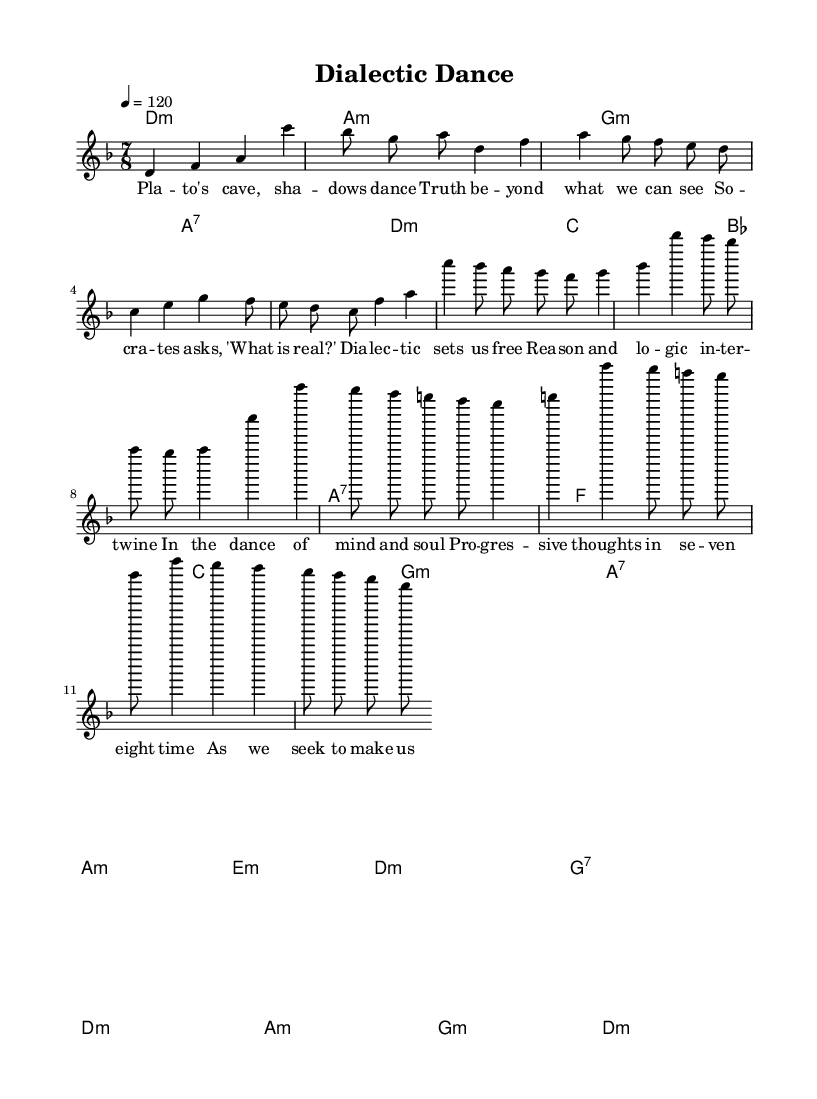What is the key signature of this music? The key signature is indicated at the beginning of the staff, showing one flat (B flat), which corresponds to D minor.
Answer: D minor What is the time signature of the piece? The time signature is found at the beginning of the music, indicating that there are seven beats per measure, which is expressed as 7/8.
Answer: 7/8 What is the tempo of the piece? The tempo marking shows "4 = 120", meaning there are 120 beats per minute, and each quarter note is to be played at this speed.
Answer: 120 How many sections are in the composition? By analyzing the structure, there are five distinct sections present: Intro, Verse, Chorus, Bridge, and Outro, as outlined in the music.
Answer: Five What is the mood conveyed through the song's title? The title "Dialectic Dance" suggests an exploration of philosophical ideas through the metaphor of dancing, implying a lively yet reflective mood.
Answer: Reflective How many words are in the first verse? The first verse has four lines of lyrics, and counting each word gives a total of 20 words.
Answer: 20 What instruments are likely used in this genre fusion? Considering the style of progressive rock-folk fusion, common instruments would include electric guitar, acoustic guitar, and keyboards, which might be inferred from the harmonies and melody.
Answer: Electric and acoustic guitars 